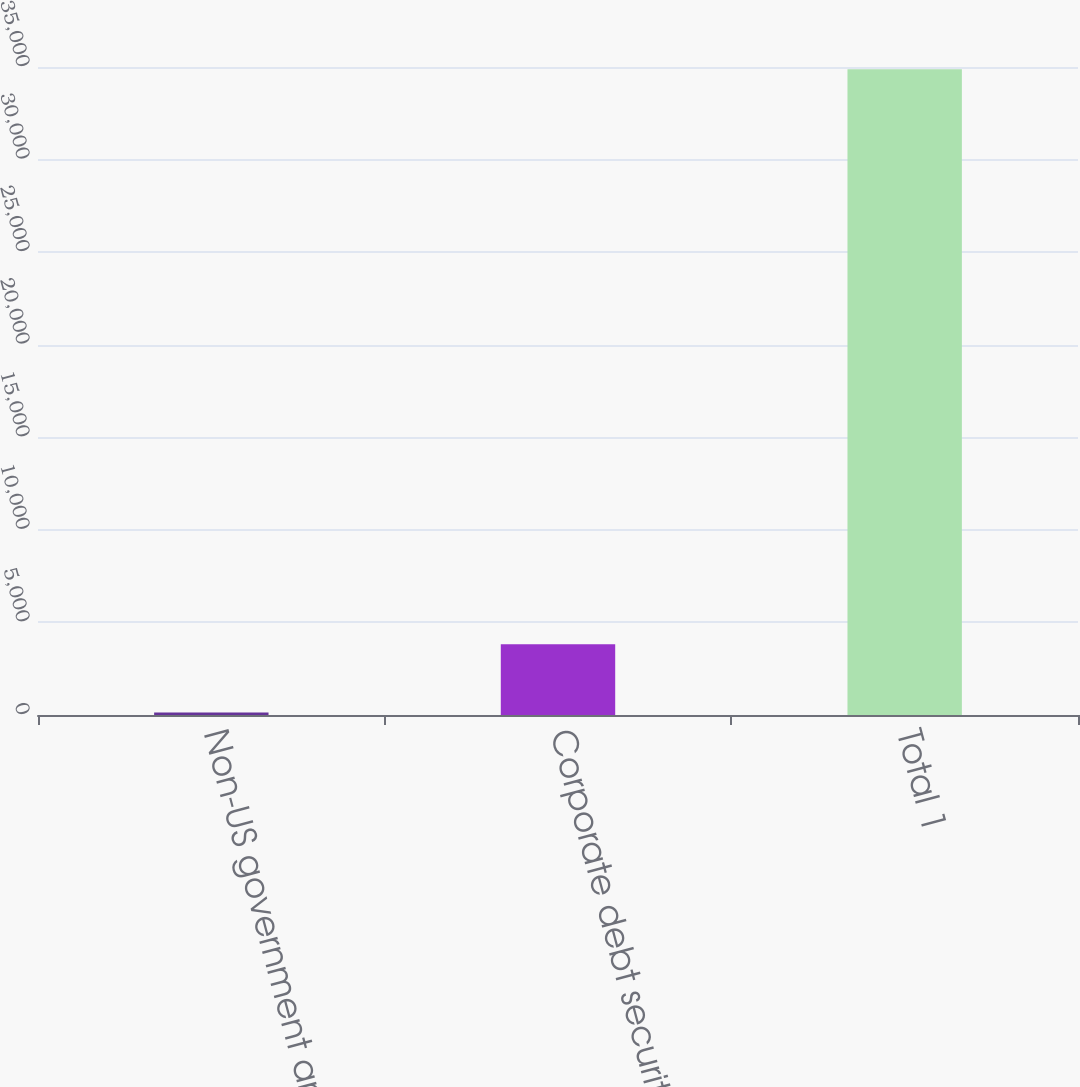Convert chart. <chart><loc_0><loc_0><loc_500><loc_500><bar_chart><fcel>Non-US government and agency<fcel>Corporate debt securities<fcel>Total 1<nl><fcel>136<fcel>3815<fcel>34875<nl></chart> 